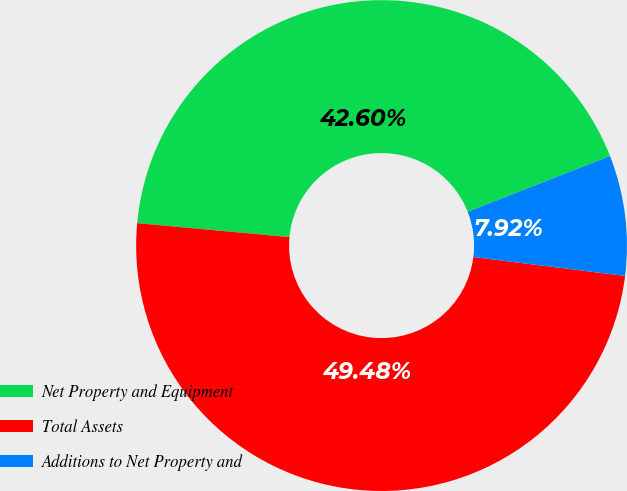Convert chart. <chart><loc_0><loc_0><loc_500><loc_500><pie_chart><fcel>Net Property and Equipment<fcel>Total Assets<fcel>Additions to Net Property and<nl><fcel>42.6%<fcel>49.48%<fcel>7.92%<nl></chart> 